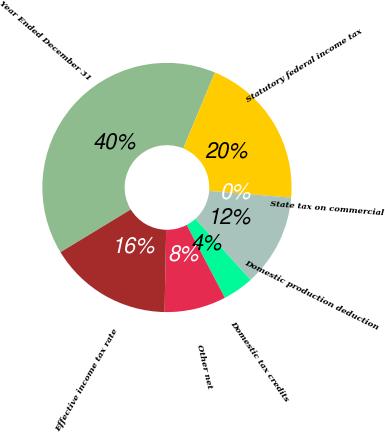Convert chart to OTSL. <chart><loc_0><loc_0><loc_500><loc_500><pie_chart><fcel>Year Ended December 31<fcel>Statutory federal income tax<fcel>State tax on commercial<fcel>Domestic production deduction<fcel>Domestic tax credits<fcel>Other net<fcel>Effective income tax rate<nl><fcel>39.99%<fcel>20.0%<fcel>0.01%<fcel>12.0%<fcel>4.01%<fcel>8.0%<fcel>16.0%<nl></chart> 